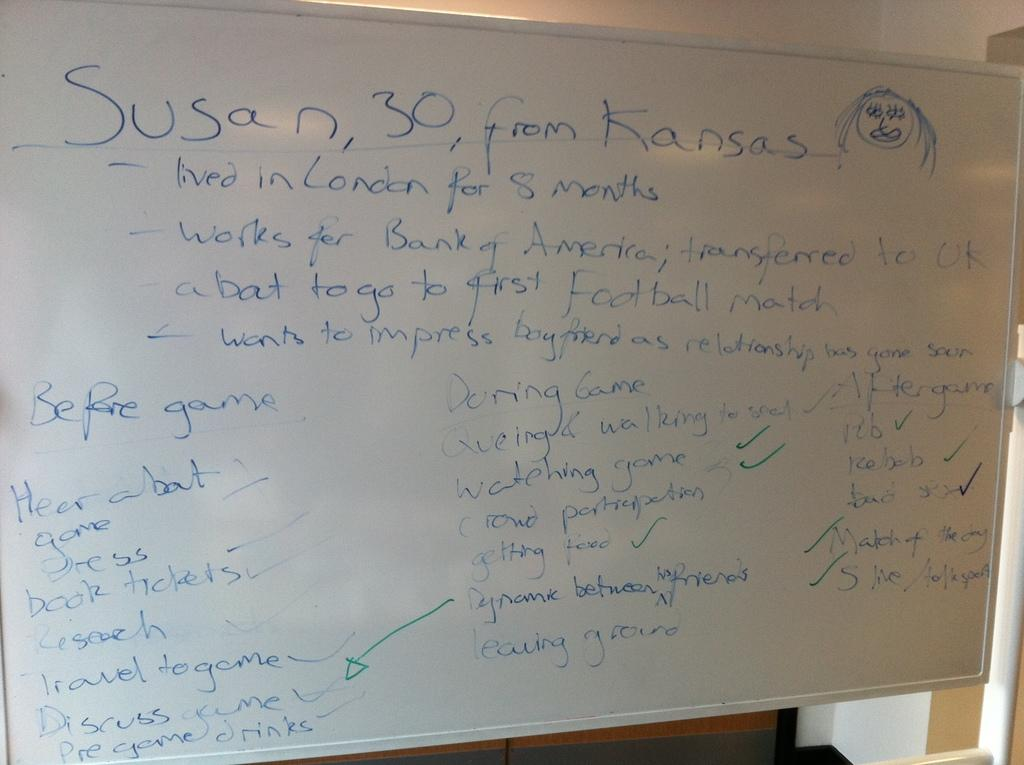<image>
Write a terse but informative summary of the picture. White board which says "30, from Kansas" on the top. 